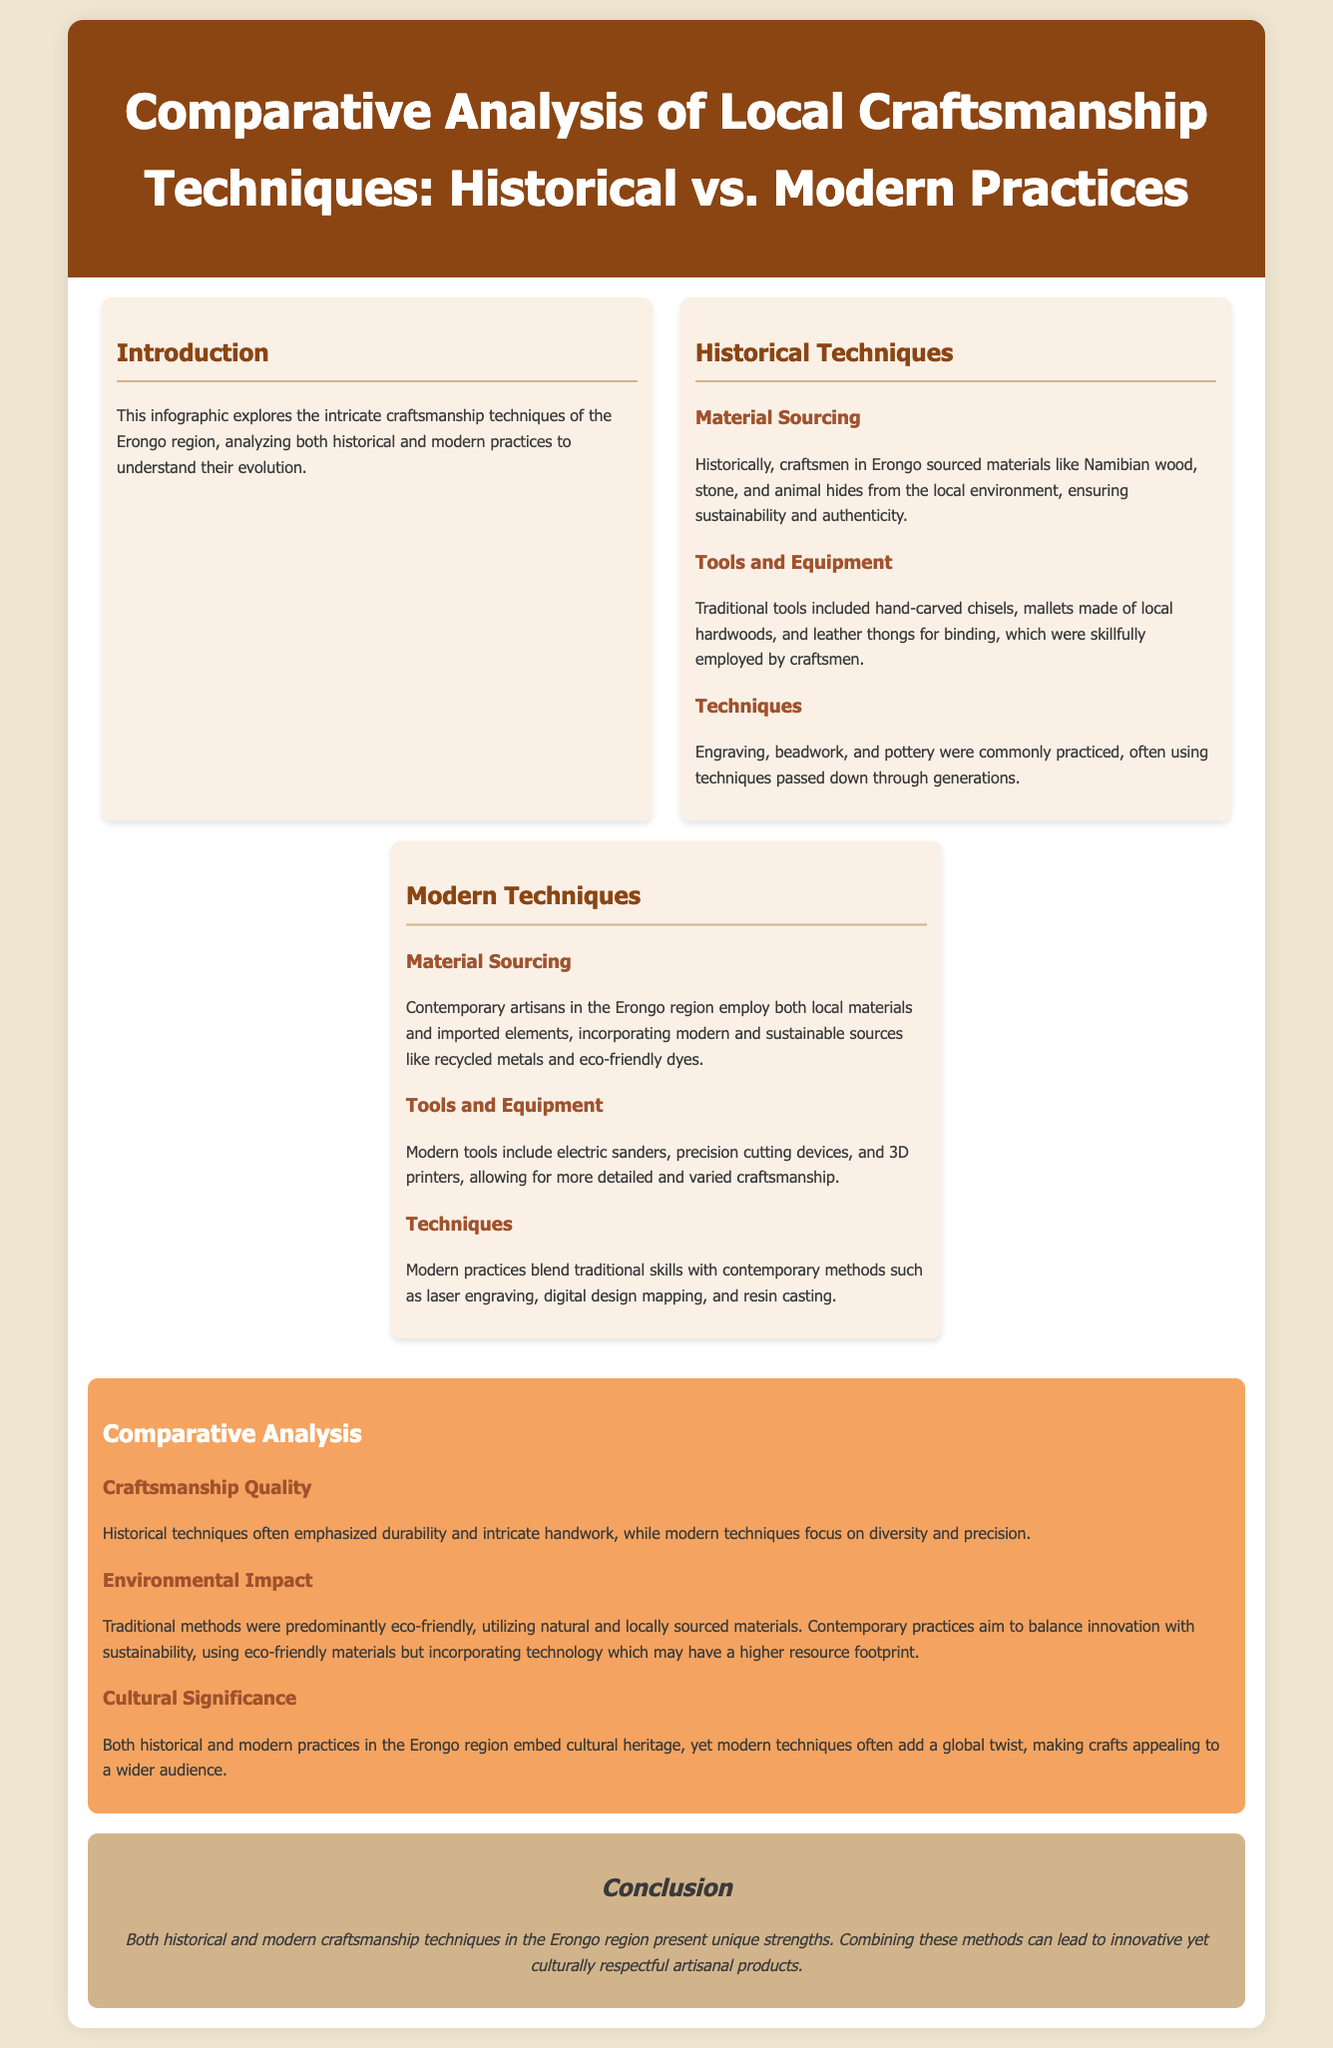What are the primary materials sourced historically? The document states that craftsmen sourced materials like Namibian wood, stone, and animal hides from the local environment.
Answer: Namibian wood, stone, and animal hides What tools were traditionally used in craftsmanship? The document describes traditional tools as hand-carved chisels, mallets made of local hardwoods, and leather thongs for binding.
Answer: Hand-carved chisels, mallets, leather thongs What modern tools are mentioned? The section on modern techniques lists tools that include electric sanders, precision cutting devices, and 3D printers.
Answer: Electric sanders, precision cutting devices, 3D printers How do historical techniques emphasize quality? The document mentions that historical techniques often emphasized durability and intricate handwork.
Answer: Durability and intricate handwork What is a significant environmental aspect of traditional methods? The document indicates that traditional methods were predominantly eco-friendly, utilizing natural and locally sourced materials.
Answer: Eco-friendly How do modern techniques differ in terms of craftsmanship focus? The modern techniques, according to the document, focus on diversity and precision in craftsmanship.
Answer: Diversity and precision What is the conclusion regarding the combination of techniques? The conclusion states that combining these methods can lead to innovative yet culturally respectful artisanal products.
Answer: Innovative yet culturally respectful products Which craftsmanship type adds a global twist? The document notes that modern techniques often add a global twist to crafts, appealing to a wider audience.
Answer: Modern techniques What does the document aim to analyze? The document's objective is to analyze the evolution of craftsmanship techniques of the Erongo region, both historical and modern.
Answer: Evolution of craftsmanship techniques 